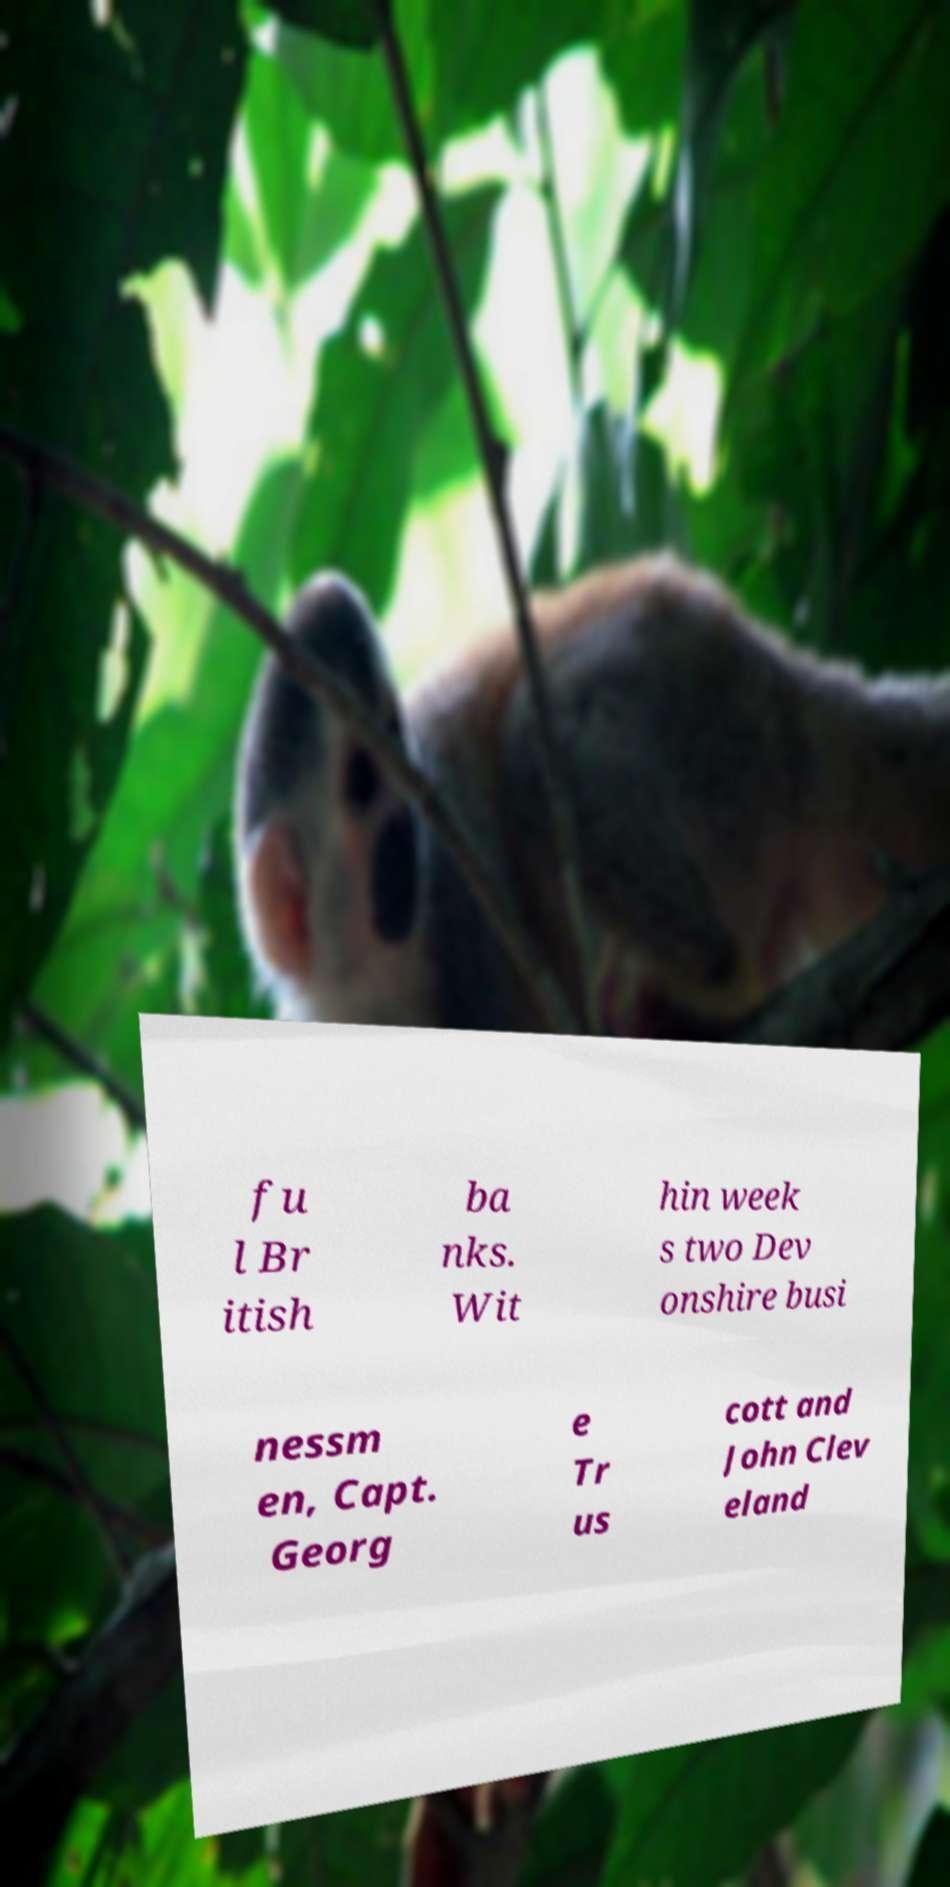What messages or text are displayed in this image? I need them in a readable, typed format. fu l Br itish ba nks. Wit hin week s two Dev onshire busi nessm en, Capt. Georg e Tr us cott and John Clev eland 